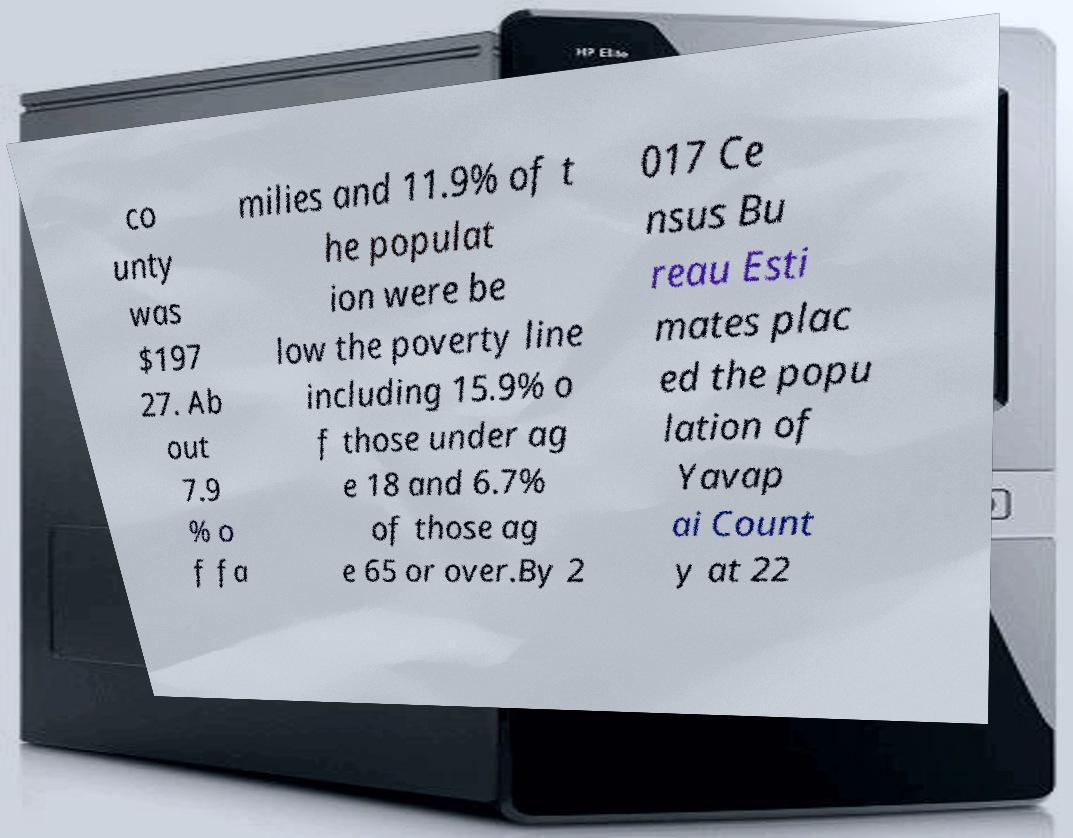I need the written content from this picture converted into text. Can you do that? co unty was $197 27. Ab out 7.9 % o f fa milies and 11.9% of t he populat ion were be low the poverty line including 15.9% o f those under ag e 18 and 6.7% of those ag e 65 or over.By 2 017 Ce nsus Bu reau Esti mates plac ed the popu lation of Yavap ai Count y at 22 